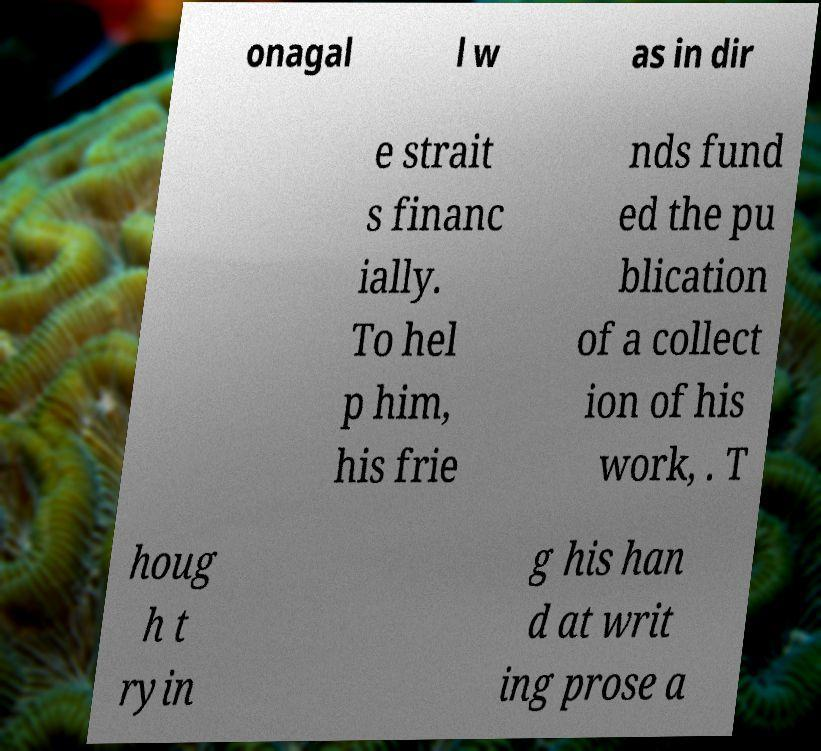Could you extract and type out the text from this image? onagal l w as in dir e strait s financ ially. To hel p him, his frie nds fund ed the pu blication of a collect ion of his work, . T houg h t ryin g his han d at writ ing prose a 